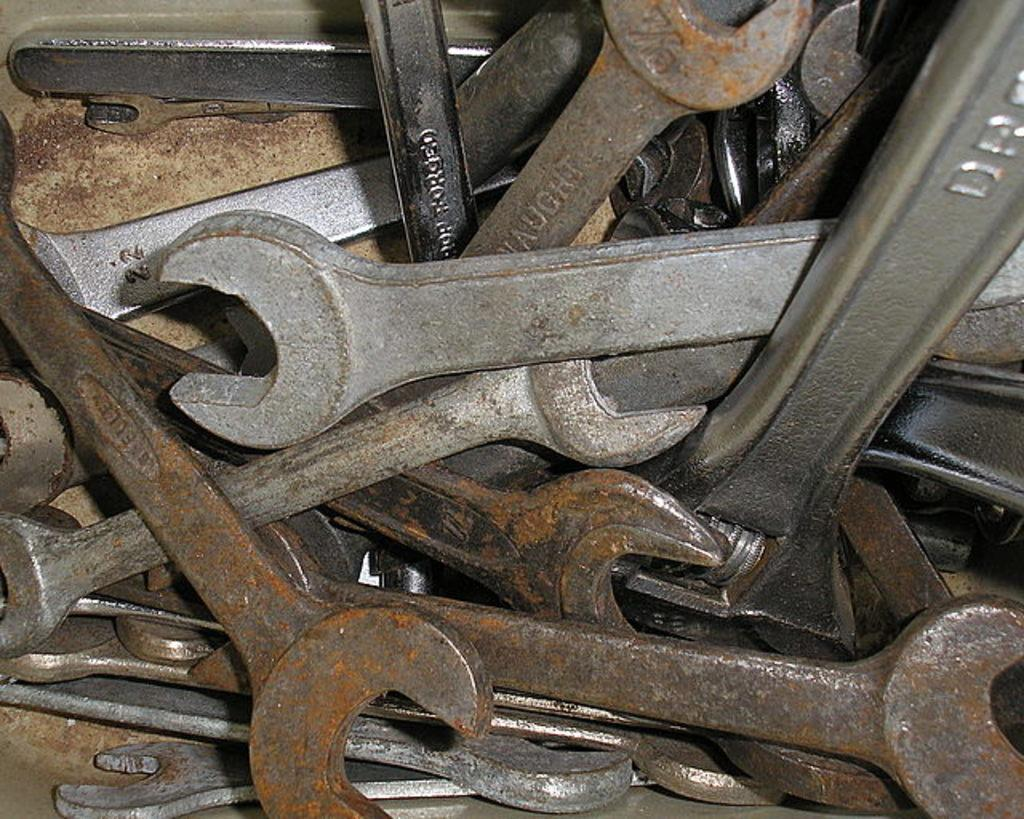What type of tools are in the image? There are iron tools in the image. Where are the iron tools located? The iron tools are in a box. Can you describe the condition of some of the tools? Some of the tools are rusted. What type of insect can be seen in the image? There are no insects present in the image. 